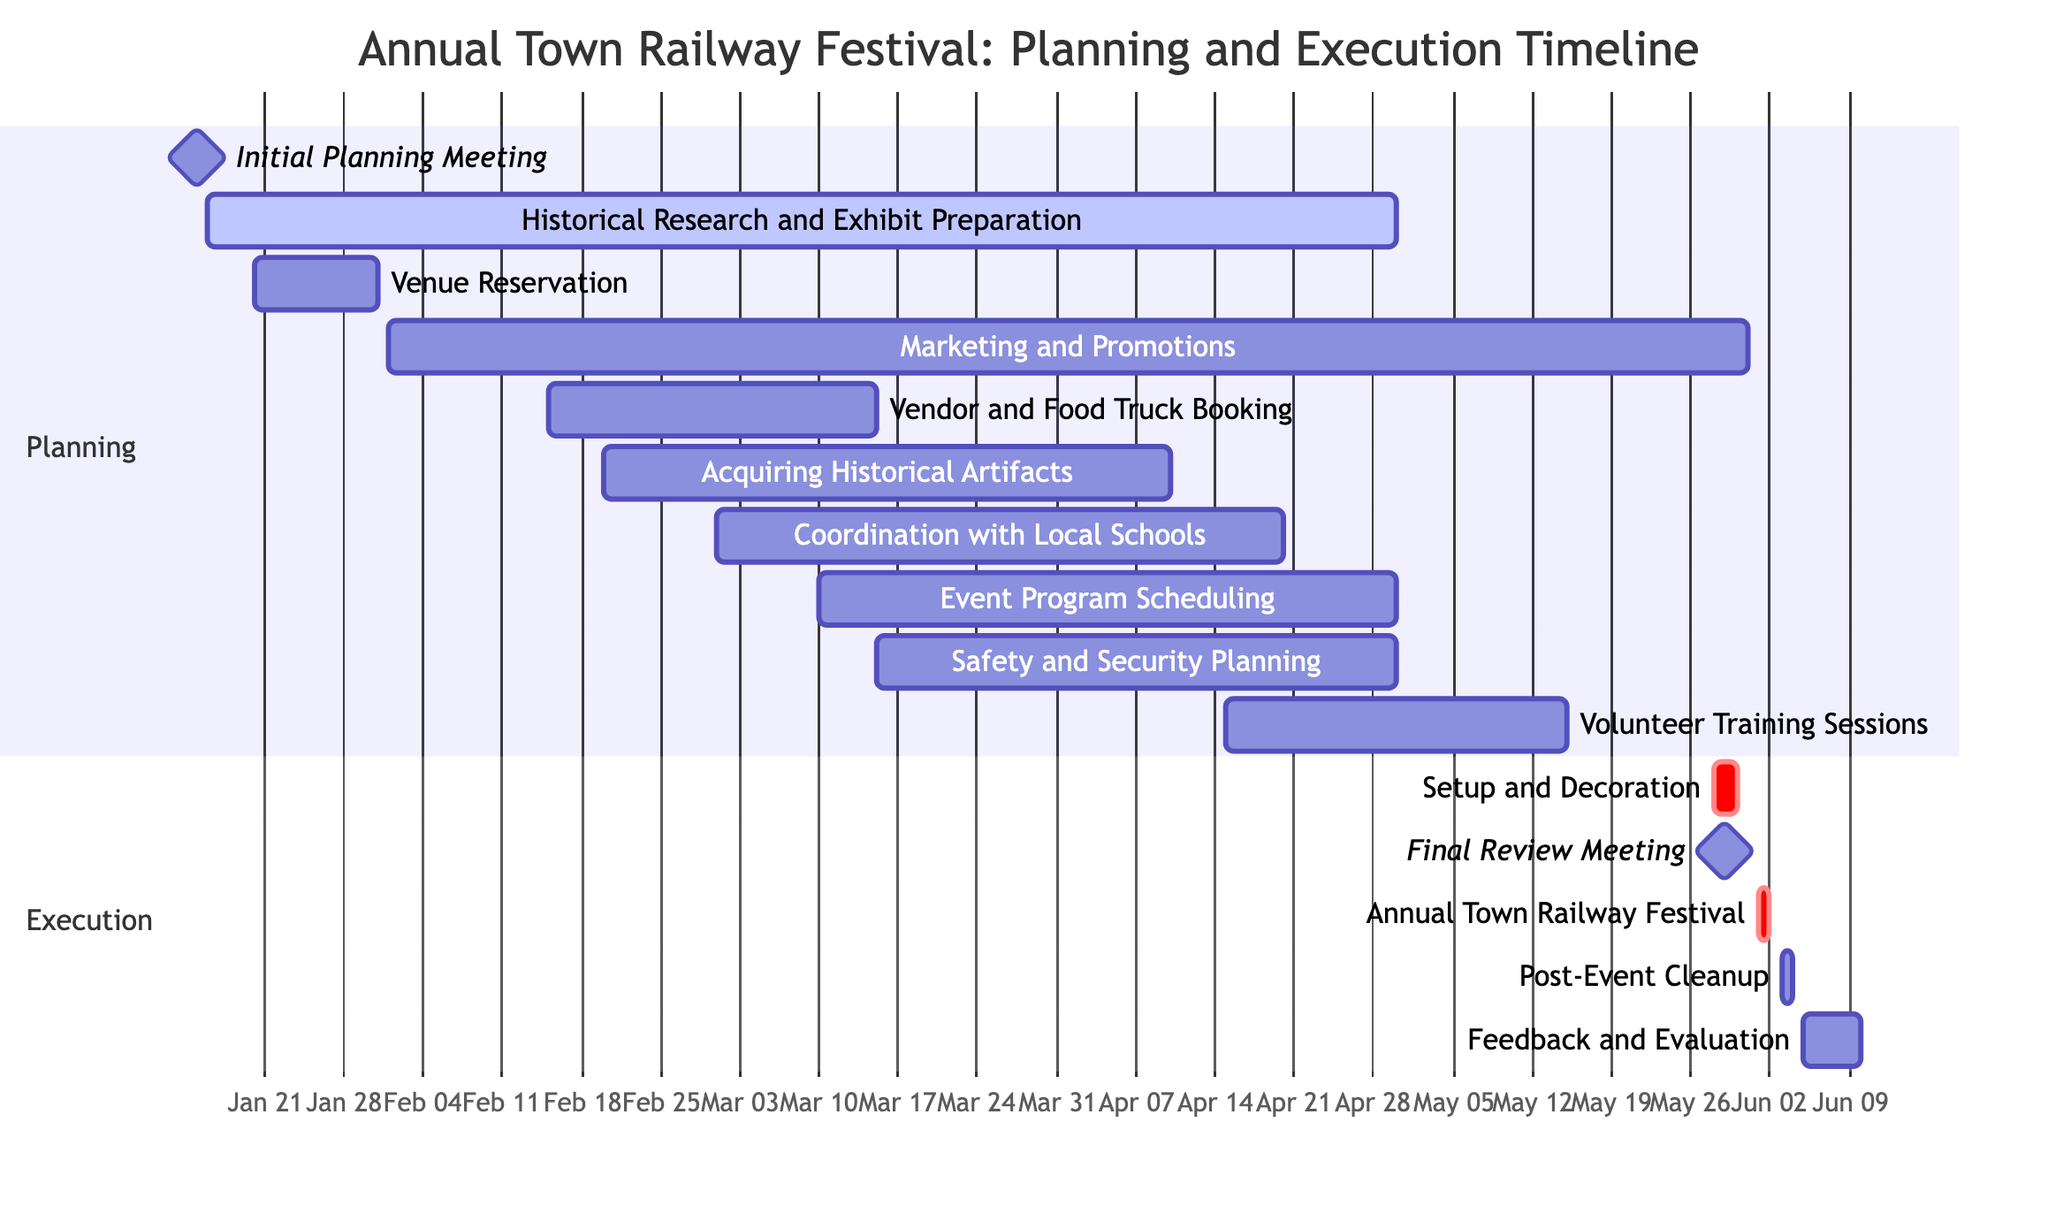What is the duration of the "Vendor and Food Truck Booking" task? The task starts on February 15, 2024, and ends on March 15, 2024. To calculate the duration, count the days from start to end: February 15 to March 15 is 30 days.
Answer: 30 days What is the start date for "Feedback and Evaluation"? The "Feedback and Evaluation" task begins on June 5, 2024, as indicated in the timeline.
Answer: June 5, 2024 How many tasks fall under the "Planning" section? The "Planning" section includes 10 tasks listed before the "Execution" section starts. To find the count, simply enumerate the tasks under "Planning".
Answer: 10 Which task overlaps with "Event Program Scheduling"? "Safety and Security Planning" has overlapping dates from March 15 to April 30, 2024, which coincides with the "Event Program Scheduling" timeline.
Answer: Safety and Security Planning What is the total timeline for the event planning process? The planning starts on January 15, 2024, with the "Initial Planning Meeting," and the final task "Feedback and Evaluation" ends on June 10, 2024. The total range spans from the start to the end date, equating to 145 days from January 15 to June 10, 2024.
Answer: 145 days Which task has the longest duration? "Historical Research and Exhibit Preparation" runs from January 16 to April 30, 2024. This is a period of 105 days, making it the longest task in the Gantt chart.
Answer: 105 days Is "Setup and Decoration" a critical task? The "Setup and Decoration" task is marked with the "crit" tag in the diagram, indicating that it is a critical task that needs to be prioritized.
Answer: Yes What occurs immediately after the "Annual Town Railway Festival"? "Post-Event Cleanup" is scheduled to occur right after the festival, starting on June 3, 2024, as per the timeline.
Answer: Post-Event Cleanup 